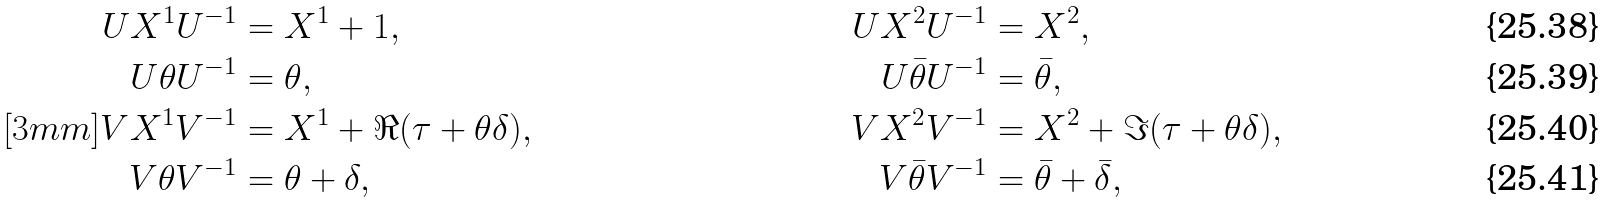<formula> <loc_0><loc_0><loc_500><loc_500>U X ^ { 1 } U ^ { - 1 } & = X ^ { 1 } + 1 , & U X ^ { 2 } U ^ { - 1 } & = X ^ { 2 } , \\ U \theta U ^ { - 1 } & = \theta , & U \bar { \theta } U ^ { - 1 } & = \bar { \theta } , \\ [ 3 m m ] V X ^ { 1 } V ^ { - 1 } & = X ^ { 1 } + \Re ( \tau + \theta \delta ) , & V X ^ { 2 } V ^ { - 1 } & = X ^ { 2 } + \Im ( \tau + \theta \delta ) , \\ V \theta V ^ { - 1 } & = \theta + \delta , & V \bar { \theta } V ^ { - 1 } & = \bar { \theta } + \bar { \delta } ,</formula> 